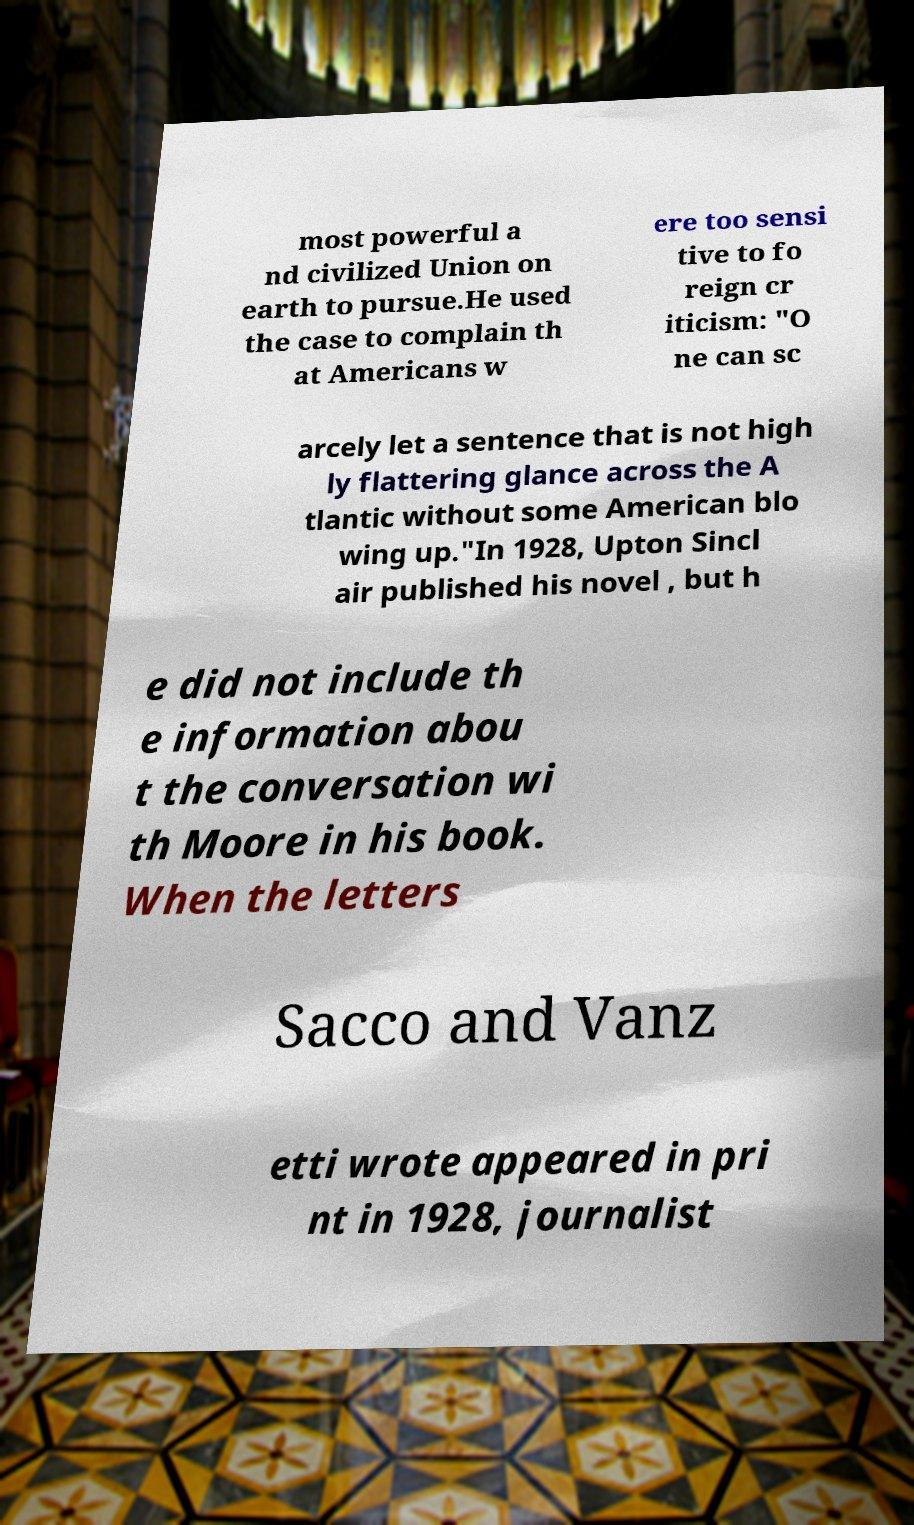There's text embedded in this image that I need extracted. Can you transcribe it verbatim? most powerful a nd civilized Union on earth to pursue.He used the case to complain th at Americans w ere too sensi tive to fo reign cr iticism: "O ne can sc arcely let a sentence that is not high ly flattering glance across the A tlantic without some American blo wing up."In 1928, Upton Sincl air published his novel , but h e did not include th e information abou t the conversation wi th Moore in his book. When the letters Sacco and Vanz etti wrote appeared in pri nt in 1928, journalist 